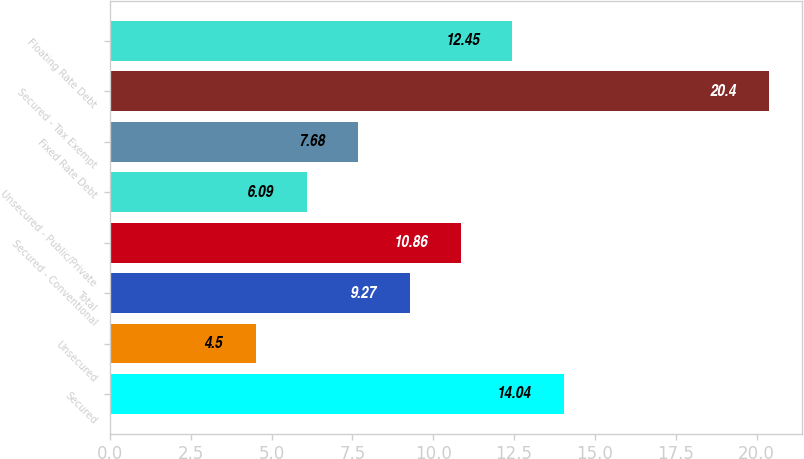<chart> <loc_0><loc_0><loc_500><loc_500><bar_chart><fcel>Secured<fcel>Unsecured<fcel>Total<fcel>Secured - Conventional<fcel>Unsecured - Public/Private<fcel>Fixed Rate Debt<fcel>Secured - Tax Exempt<fcel>Floating Rate Debt<nl><fcel>14.04<fcel>4.5<fcel>9.27<fcel>10.86<fcel>6.09<fcel>7.68<fcel>20.4<fcel>12.45<nl></chart> 